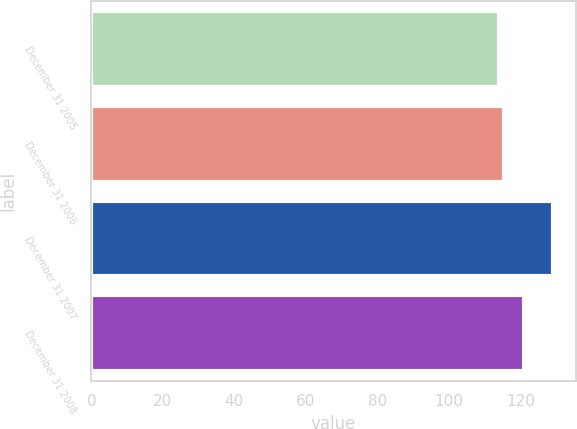<chart> <loc_0><loc_0><loc_500><loc_500><bar_chart><fcel>December 31 2005<fcel>December 31 2006<fcel>December 31 2007<fcel>December 31 2008<nl><fcel>114<fcel>115.5<fcel>129<fcel>121<nl></chart> 